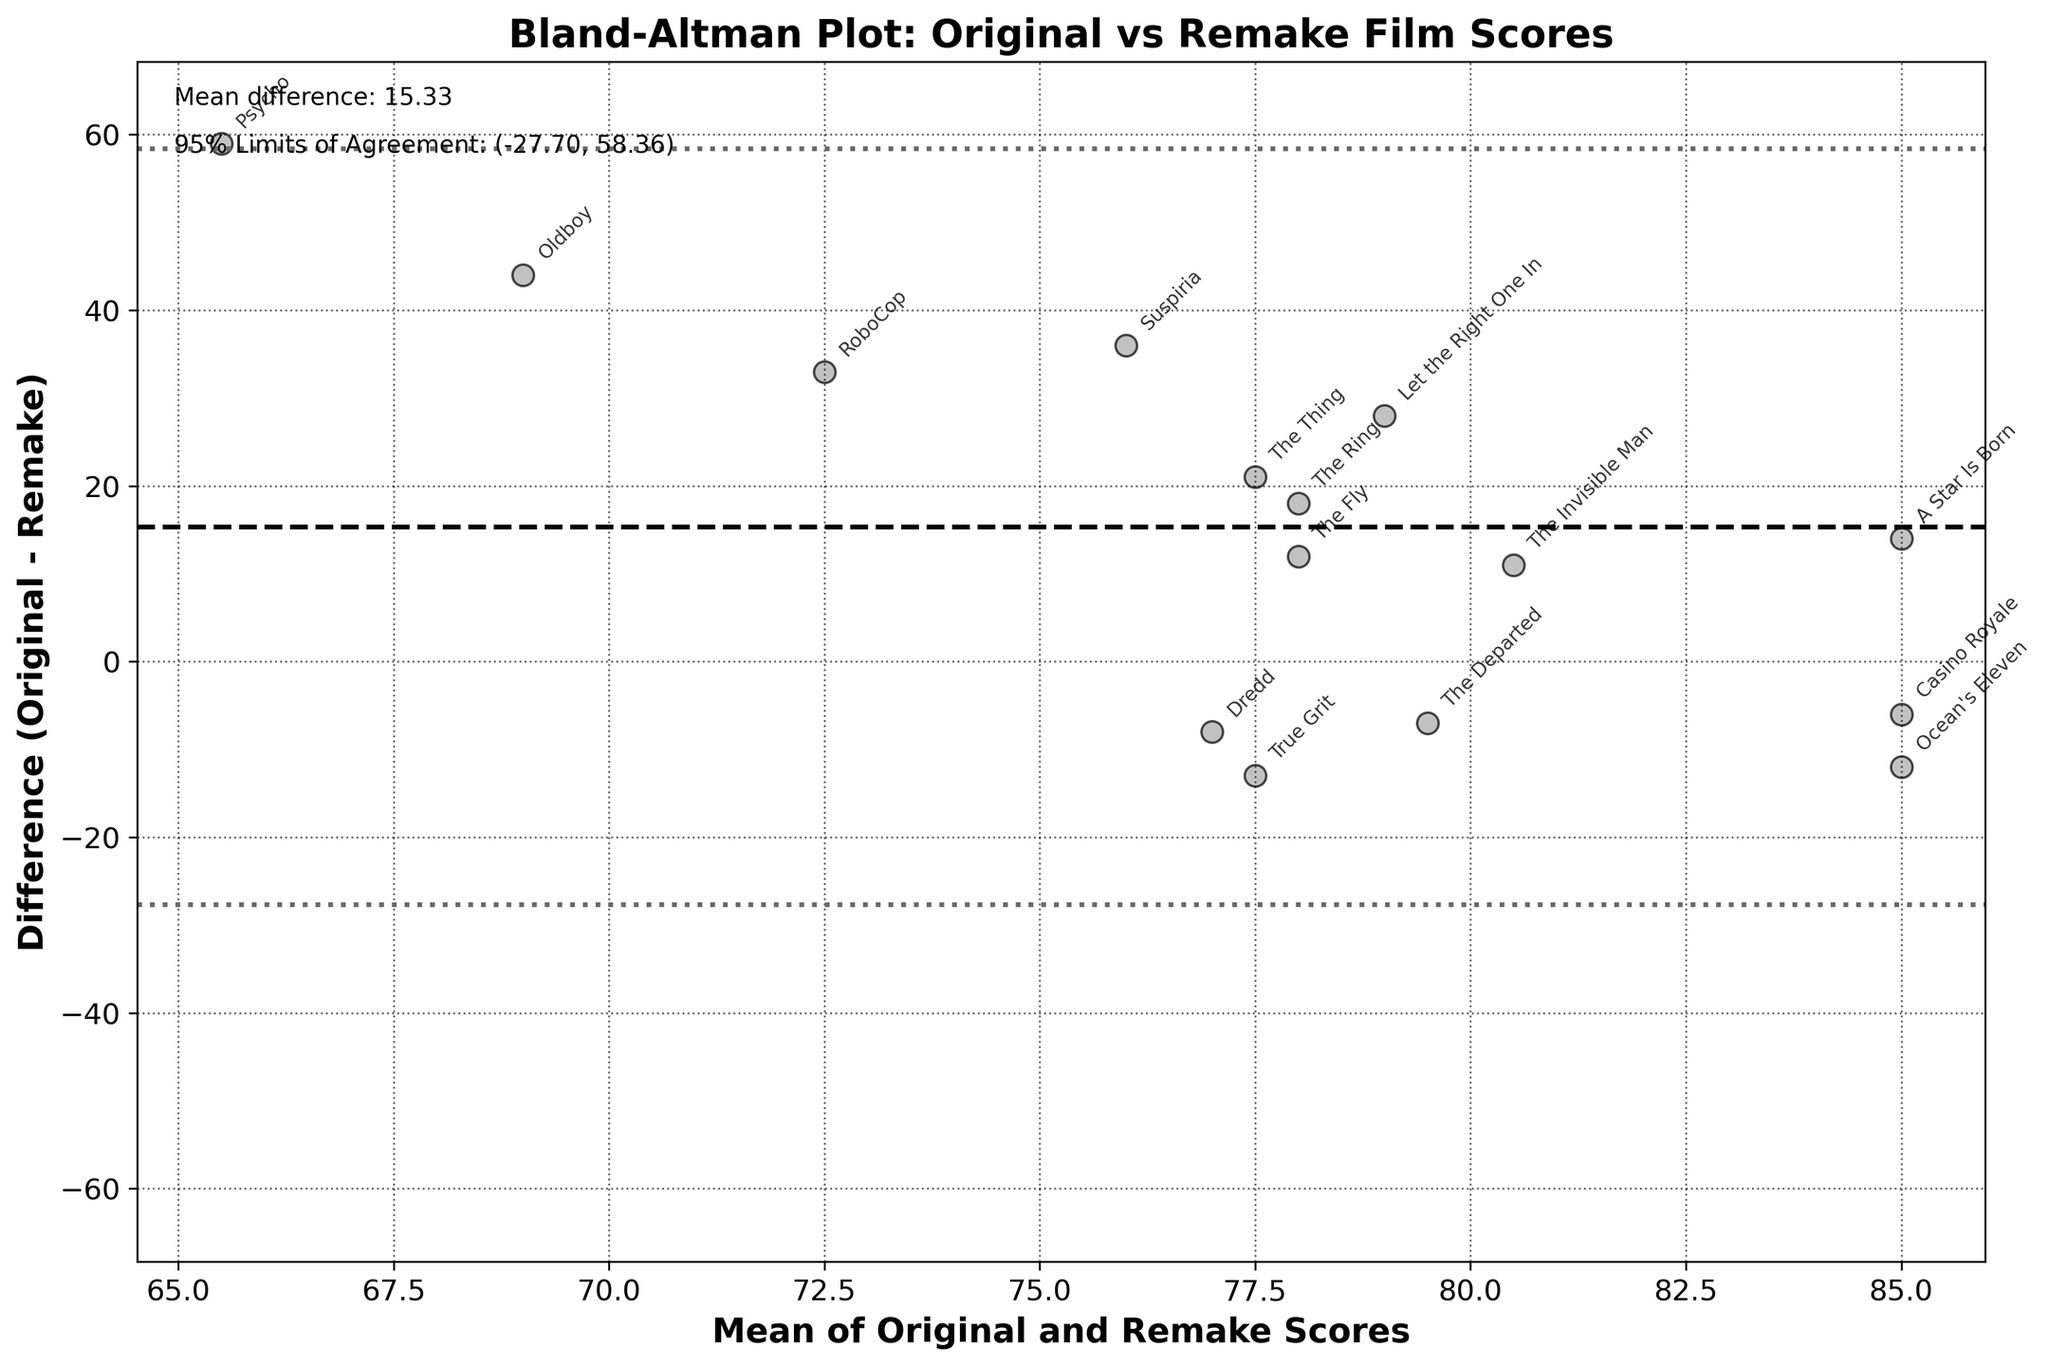What is the title of the plot? The title is centered at the top of the plot and reads "Bland-Altman Plot: Original vs Remake Film Scores."
Answer: Bland-Altman Plot: Original vs Remake Film Scores What is the average difference between the original and remake scores? The mean difference is explicitly mentioned in the text at the top left corner of the plot. It states "Mean difference: 18.80."
Answer: 18.80 How many films have their original scores significantly higher than their remake scores, outside the 95% limits of agreement? Points beyond the dashed lines representing the 95% limits of agreement can be counted. There are two such points: "Psycho" and "Oldboy."
Answer: 2 Which film has the greatest difference in scores between the original and the remake? By observing the largest vertical distance from the mean difference line, "Psycho" shows the greatest difference.
Answer: Psycho What are the 95% limits of agreement? The 95% limits of agreement are shown as dashed lines and are indicated with text at the top left corner of the plot as "(5.81, 31.79)."
Answer: (5.81, 31.79) Which film has the closest difference to the mean difference? The film nearest the solid mean difference line visually is "The Fly."
Answer: The Fly What can you say about the relationship between the mean of scores and their differences? Points are scattered without a clear trend, indicating that there is no strong relationship between the mean of scores and the differences. This implies variability in how much remakes deviate from their originals as the overall score changes.
Answer: No strong relationship Are there more films whose remakes scored higher than their original films or the opposite? By counting the points above and below the mean difference line, more points lie above, indicating more remakes scored lower than their originals.
Answer: More remakes scored lower than originals Is the standard deviation of the differences provided? The plot text at the top left does not provide a standard deviation value but mentions the 95% limits of agreement which can be used to infer the spread.
Answer: Not directly provided 